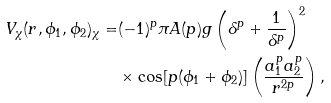<formula> <loc_0><loc_0><loc_500><loc_500>V _ { \chi } ( r , \phi _ { 1 } , \phi _ { 2 } ) _ { \chi } = & ( - 1 ) ^ { p } \pi A ( p ) g \left ( \delta ^ { p } + \frac { 1 } { \delta ^ { p } } \right ) ^ { 2 } \\ & \times \cos [ p ( \phi _ { 1 } + \phi _ { 2 } ) ] \left ( \frac { a _ { 1 } ^ { p } a _ { 2 } ^ { p } } { r ^ { 2 p } } \right ) ,</formula> 